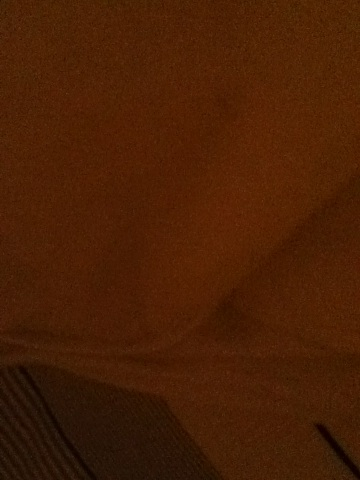What is this picture of? In detail. It is difficult to determine the exact content of this picture due to the low lighting and unclear details. It appears to be a close-up of a fabric with a pattern, possibly under dim lighting conditions. 